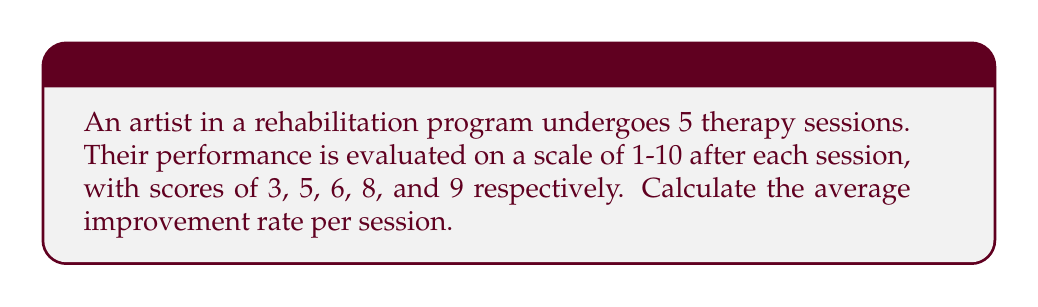Could you help me with this problem? To calculate the average improvement rate per session:

1. Calculate total improvement:
   $\text{Total improvement} = \text{Final score} - \text{Initial score}$
   $\text{Total improvement} = 9 - 3 = 6$

2. Calculate number of improvements:
   $\text{Number of improvements} = \text{Number of sessions} - 1 = 5 - 1 = 4$

3. Calculate average improvement rate:
   $$\text{Average improvement rate} = \frac{\text{Total improvement}}{\text{Number of improvements}}$$
   $$\text{Average improvement rate} = \frac{6}{4} = 1.5$$

Therefore, the average improvement rate per session is 1.5 points.
Answer: 1.5 points per session 